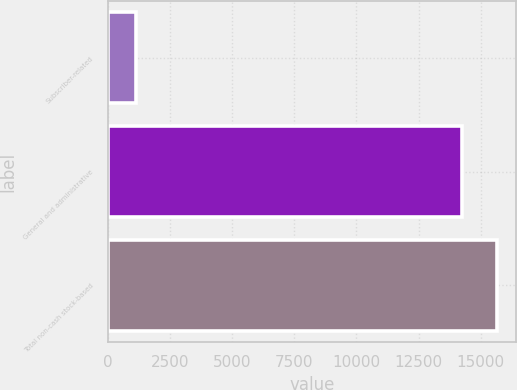Convert chart to OTSL. <chart><loc_0><loc_0><loc_500><loc_500><bar_chart><fcel>Subscriber-related<fcel>General and administrative<fcel>Total non-cash stock-based<nl><fcel>1160<fcel>14227<fcel>15649.7<nl></chart> 